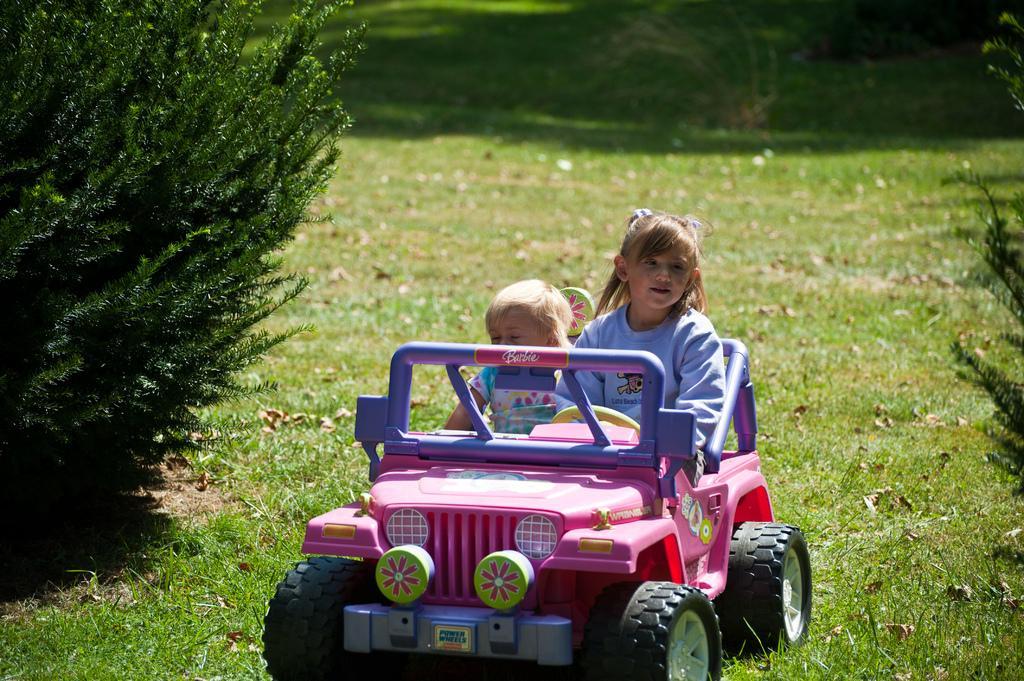Please provide a concise description of this image. In this image, we can see kids in a pink jeep. There is a plant on the left side of the image. There is a grass on the ground. 